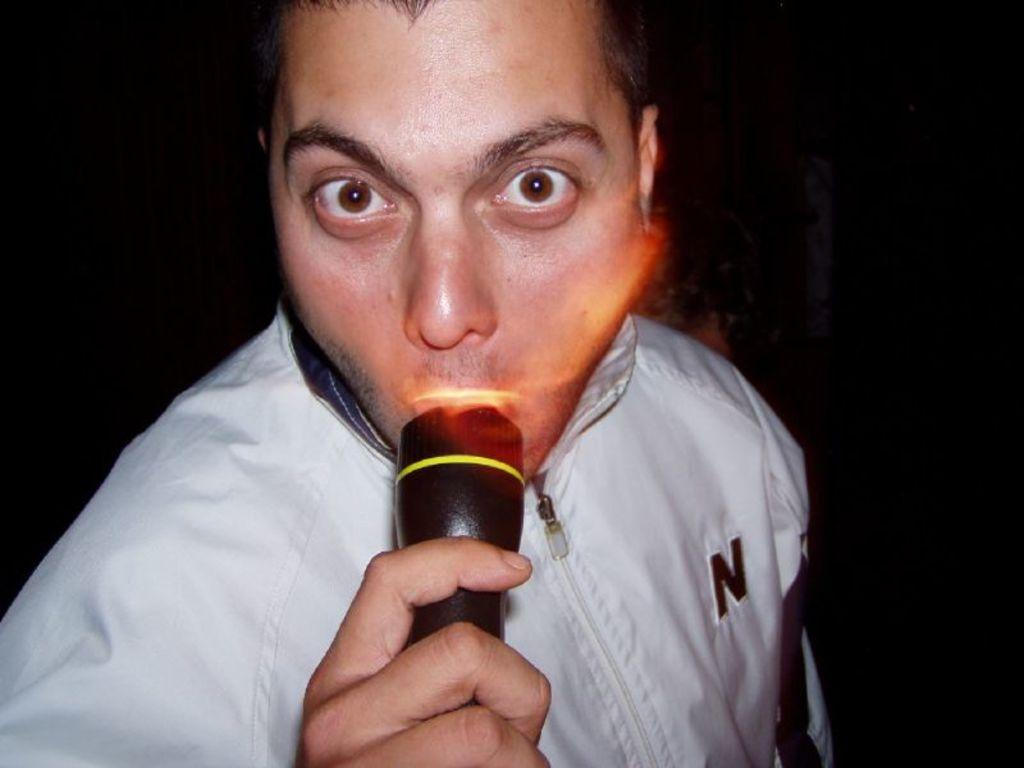Who is present in the image? There is a man in the image. What is the man holding in the image? The man is holding a flashlight. What can be inferred about the lighting conditions in the image? The background of the image is dark. What type of planes can be seen flying in the image? There are no planes visible in the image; it only features a man holding a flashlight with a dark background. What mark or paint is visible on the man's face in the image? There is no mark or paint visible on the man's face in the image. 